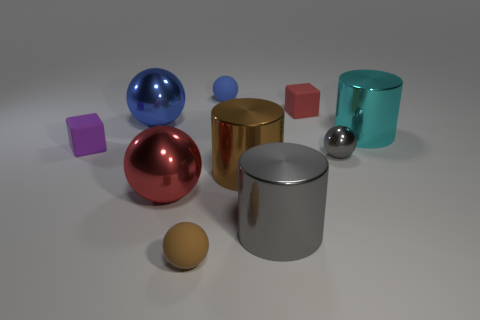Subtract all gray spheres. How many spheres are left? 4 Subtract all tiny metallic balls. How many balls are left? 4 Subtract 2 spheres. How many spheres are left? 3 Subtract all yellow spheres. Subtract all blue blocks. How many spheres are left? 5 Subtract all cylinders. How many objects are left? 7 Add 2 large yellow metallic spheres. How many large yellow metallic spheres exist? 2 Subtract 1 brown cylinders. How many objects are left? 9 Subtract all big purple matte cylinders. Subtract all gray metal spheres. How many objects are left? 9 Add 8 red metal spheres. How many red metal spheres are left? 9 